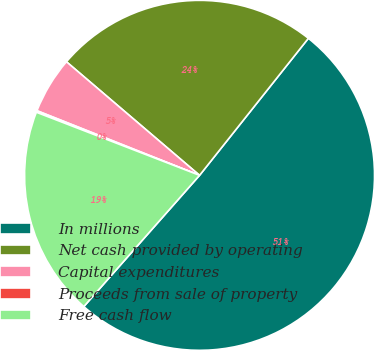Convert chart. <chart><loc_0><loc_0><loc_500><loc_500><pie_chart><fcel>In millions<fcel>Net cash provided by operating<fcel>Capital expenditures<fcel>Proceeds from sale of property<fcel>Free cash flow<nl><fcel>50.82%<fcel>24.44%<fcel>5.22%<fcel>0.15%<fcel>19.37%<nl></chart> 